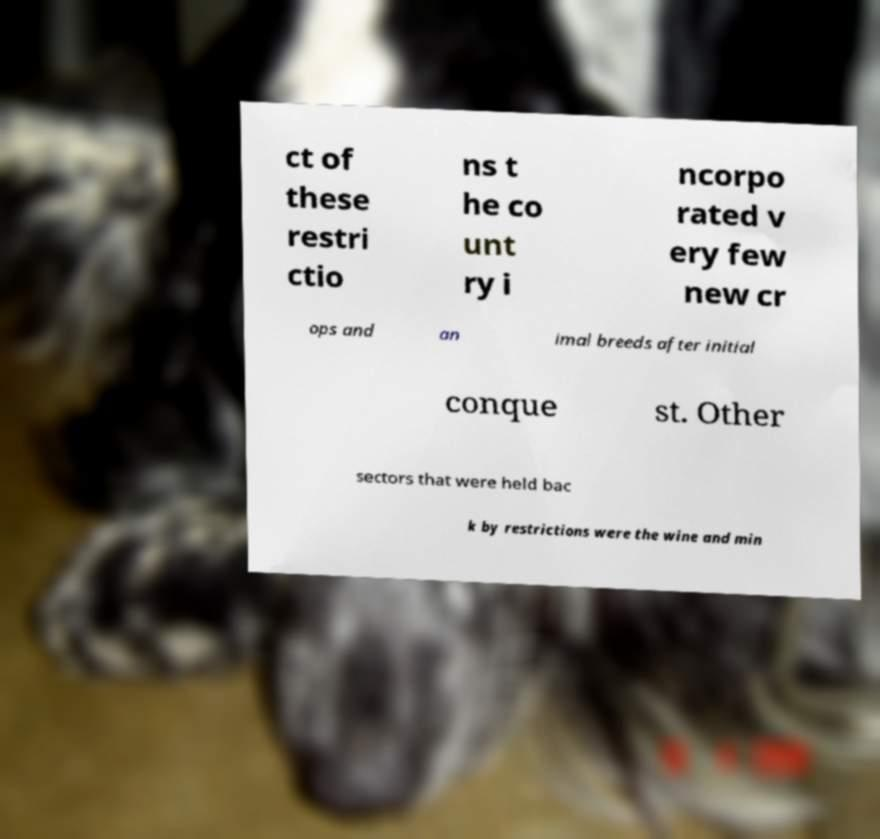What messages or text are displayed in this image? I need them in a readable, typed format. ct of these restri ctio ns t he co unt ry i ncorpo rated v ery few new cr ops and an imal breeds after initial conque st. Other sectors that were held bac k by restrictions were the wine and min 